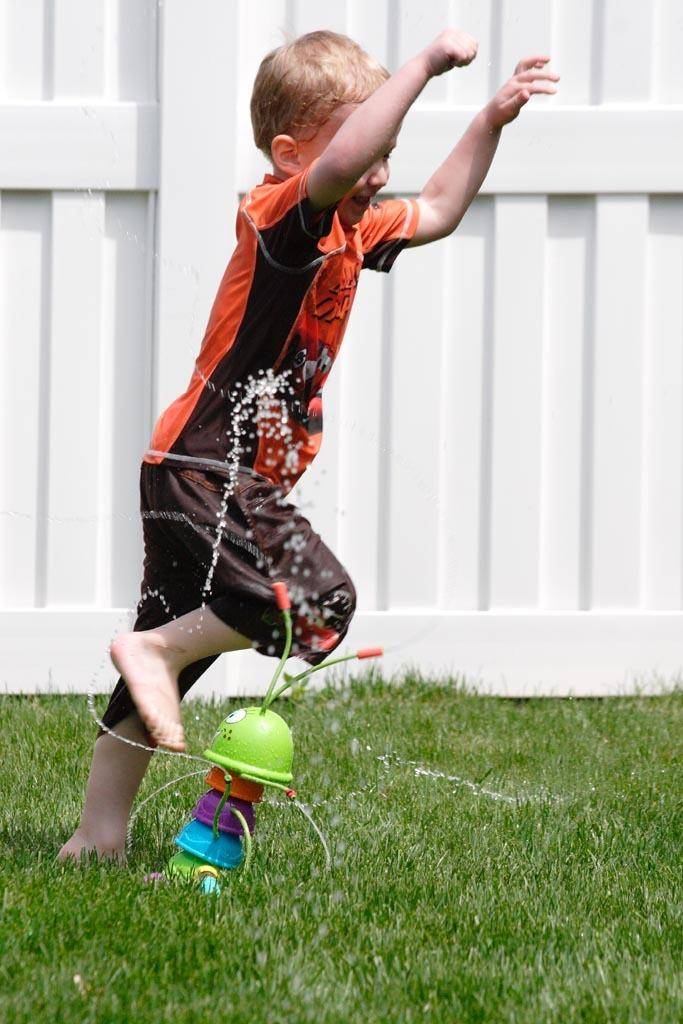Who is present in the image? There is a boy in the image. What is located on the grass in the image? There is a toy on the grass in the image. What can be seen in the background of the image? There is a whiteboard in the background of the image. What type of digestion is the boy experiencing in the image? There is no indication of digestion in the image; it simply shows a boy with a toy on the grass and a whiteboard in the background. 